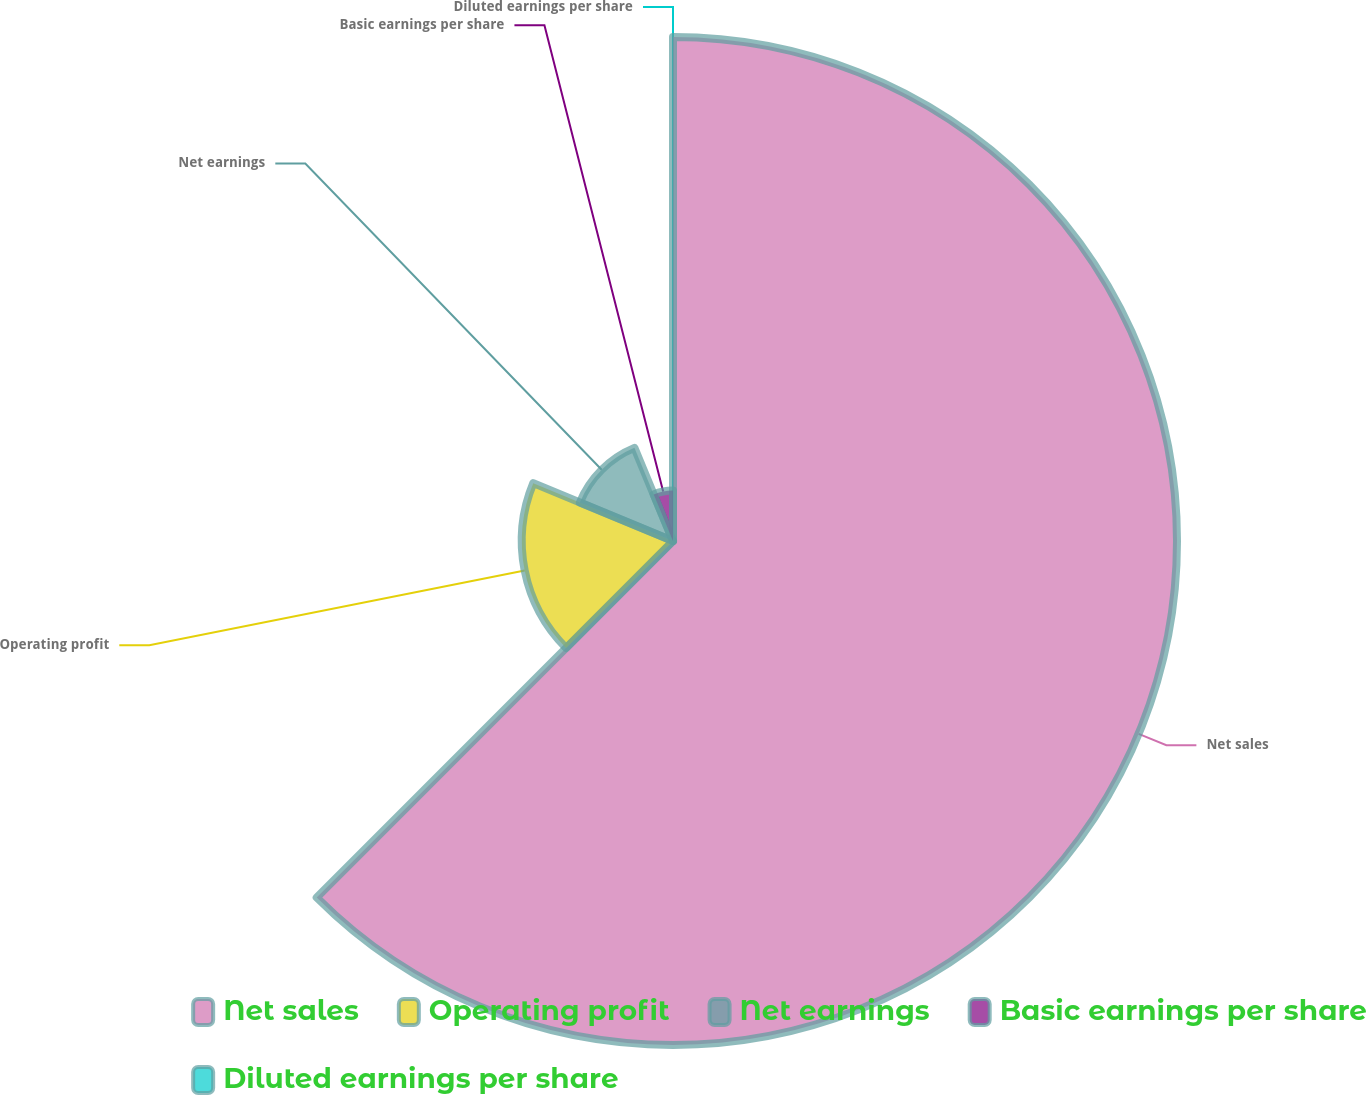Convert chart. <chart><loc_0><loc_0><loc_500><loc_500><pie_chart><fcel>Net sales<fcel>Operating profit<fcel>Net earnings<fcel>Basic earnings per share<fcel>Diluted earnings per share<nl><fcel>62.49%<fcel>18.75%<fcel>12.5%<fcel>6.25%<fcel>0.0%<nl></chart> 